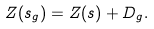<formula> <loc_0><loc_0><loc_500><loc_500>Z ( s _ { g } ) = Z ( s ) + D _ { g } .</formula> 